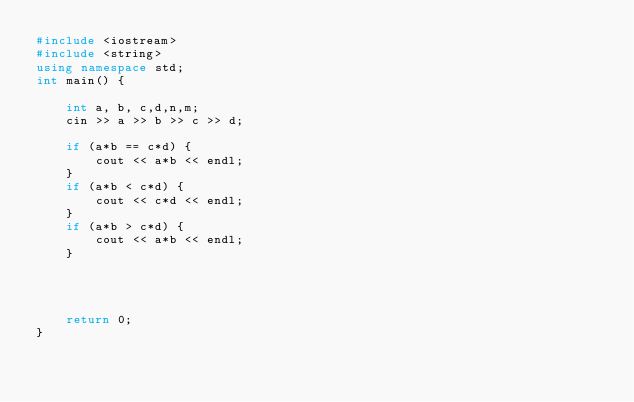<code> <loc_0><loc_0><loc_500><loc_500><_C++_>#include <iostream>
#include <string>
using namespace std;
int main() {

	int a, b, c,d,n,m;
	cin >> a >> b >> c >> d;

	if (a*b == c*d) {
		cout << a*b << endl;
	}
    if (a*b < c*d) {
		cout << c*d << endl;
	}
	if (a*b > c*d) {
		cout << a*b << endl;
	}

		
		

	return 0;
}</code> 